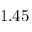<formula> <loc_0><loc_0><loc_500><loc_500>1 . 4 5</formula> 